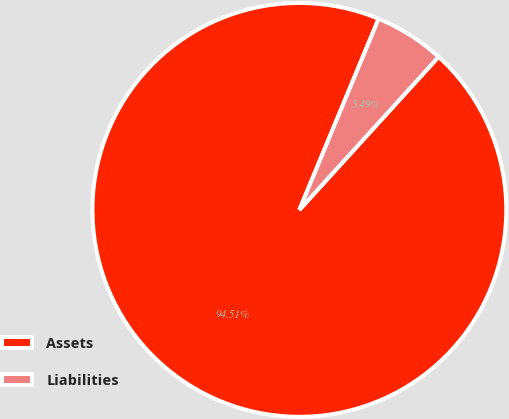Convert chart. <chart><loc_0><loc_0><loc_500><loc_500><pie_chart><fcel>Assets<fcel>Liabilities<nl><fcel>94.51%<fcel>5.49%<nl></chart> 